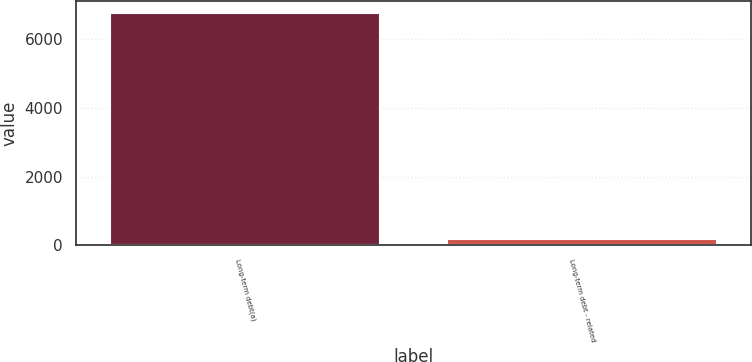<chart> <loc_0><loc_0><loc_500><loc_500><bar_chart><fcel>Long-term debt(a)<fcel>Long-term debt - related<nl><fcel>6750<fcel>178<nl></chart> 